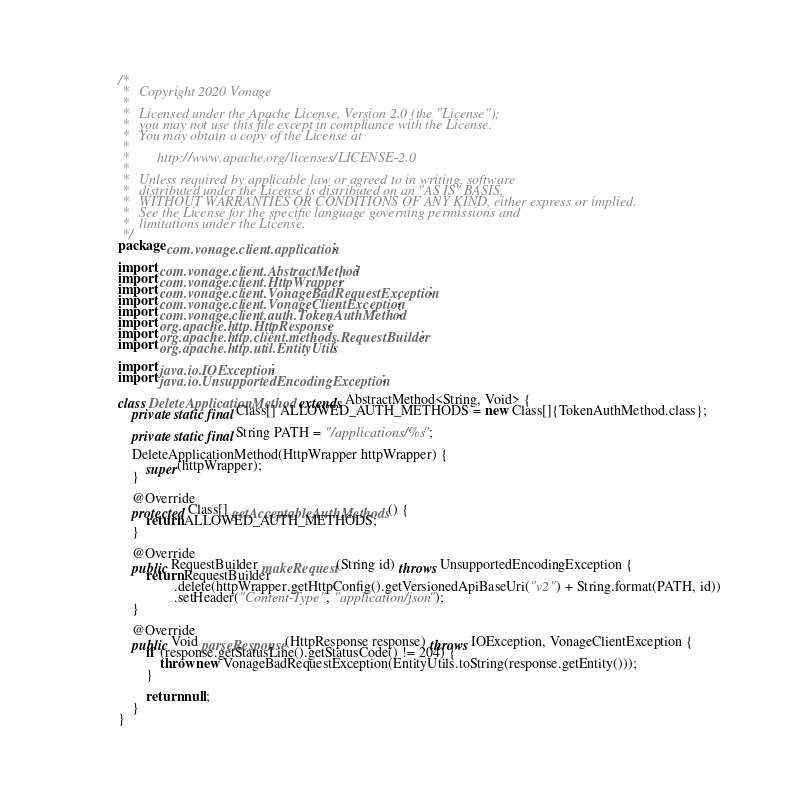<code> <loc_0><loc_0><loc_500><loc_500><_Java_>/*
 *   Copyright 2020 Vonage
 *
 *   Licensed under the Apache License, Version 2.0 (the "License");
 *   you may not use this file except in compliance with the License.
 *   You may obtain a copy of the License at
 *
 *        http://www.apache.org/licenses/LICENSE-2.0
 *
 *   Unless required by applicable law or agreed to in writing, software
 *   distributed under the License is distributed on an "AS IS" BASIS,
 *   WITHOUT WARRANTIES OR CONDITIONS OF ANY KIND, either express or implied.
 *   See the License for the specific language governing permissions and
 *   limitations under the License.
 */
package com.vonage.client.application;

import com.vonage.client.AbstractMethod;
import com.vonage.client.HttpWrapper;
import com.vonage.client.VonageBadRequestException;
import com.vonage.client.VonageClientException;
import com.vonage.client.auth.TokenAuthMethod;
import org.apache.http.HttpResponse;
import org.apache.http.client.methods.RequestBuilder;
import org.apache.http.util.EntityUtils;

import java.io.IOException;
import java.io.UnsupportedEncodingException;

class DeleteApplicationMethod extends AbstractMethod<String, Void> {
    private static final Class[] ALLOWED_AUTH_METHODS = new Class[]{TokenAuthMethod.class};

    private static final String PATH = "/applications/%s";

    DeleteApplicationMethod(HttpWrapper httpWrapper) {
        super(httpWrapper);
    }

    @Override
    protected Class[] getAcceptableAuthMethods() {
        return ALLOWED_AUTH_METHODS;
    }

    @Override
    public RequestBuilder makeRequest(String id) throws UnsupportedEncodingException {
        return RequestBuilder
                .delete(httpWrapper.getHttpConfig().getVersionedApiBaseUri("v2") + String.format(PATH, id))
                .setHeader("Content-Type", "application/json");
    }

    @Override
    public Void parseResponse(HttpResponse response) throws IOException, VonageClientException {
        if (response.getStatusLine().getStatusCode() != 204) {
            throw new VonageBadRequestException(EntityUtils.toString(response.getEntity()));
        }

        return null;
    }
}
</code> 